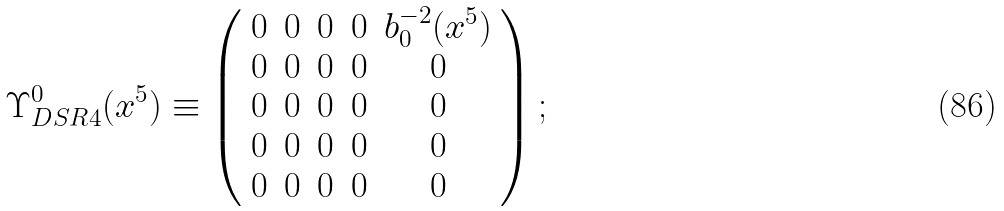<formula> <loc_0><loc_0><loc_500><loc_500>\Upsilon _ { D S R 4 } ^ { 0 } ( x ^ { 5 } ) \equiv \left ( \begin{array} { c c c c c } 0 & 0 & 0 & 0 & b _ { 0 } ^ { - 2 } ( x ^ { 5 } ) \\ 0 & 0 & 0 & 0 & 0 \\ 0 & 0 & 0 & 0 & 0 \\ 0 & 0 & 0 & 0 & 0 \\ 0 & 0 & 0 & 0 & 0 \end{array} \right ) ;</formula> 